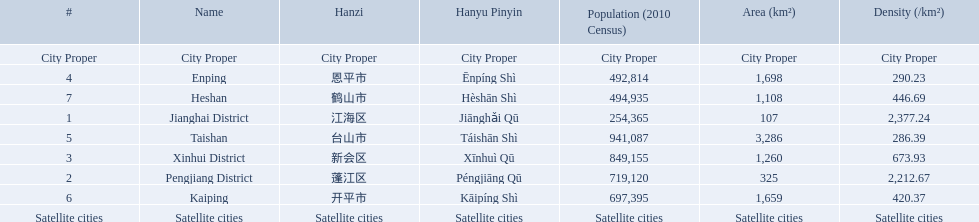What cities are there in jiangmen? Jianghai District, Pengjiang District, Xinhui District, Enping, Taishan, Kaiping, Heshan. Of those, which ones are a city proper? Jianghai District, Pengjiang District, Xinhui District. Of those, which one has the smallest area in km2? Jianghai District. 